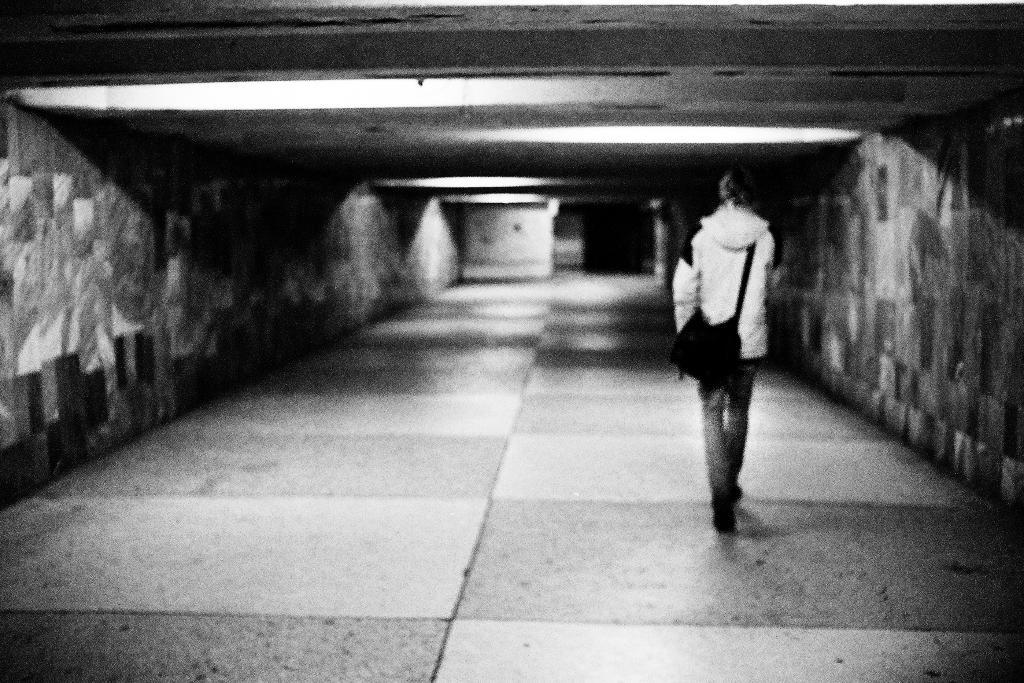What is the main subject of the image? There is a person in the image. What is the person doing in the image? The person is walking. On which side of the image is the person located? The person is on the right side of the image. What type of clothing is the person wearing? The person is wearing trousers and a sweater. What is the person carrying in the image? The person is carrying a bag. What type of zinc can be seen near the person in the image? There is no zinc present in the image. Is there a lake visible in the background of the image? There is no lake visible in the image. 